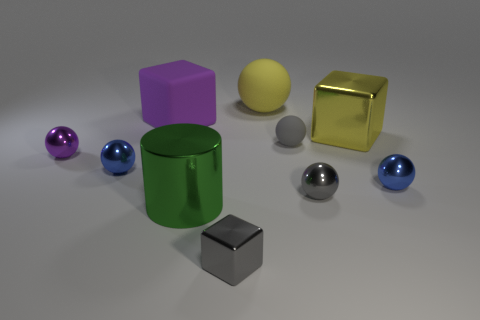What might be the purpose of arranging these objects in such a way? The arrangement of objects in this image appears deliberate, potentially for an educational or illustrative purpose. It could serve as a visual aid to teach concepts like geometry, color theory, or the interplay between light and various surface textures. Alternatively, this setup could be a simplistic artistic composition designed to provide visual pleasure or to study the fundamental principles of still life photography, focusing on form, balance, and color harmony. 